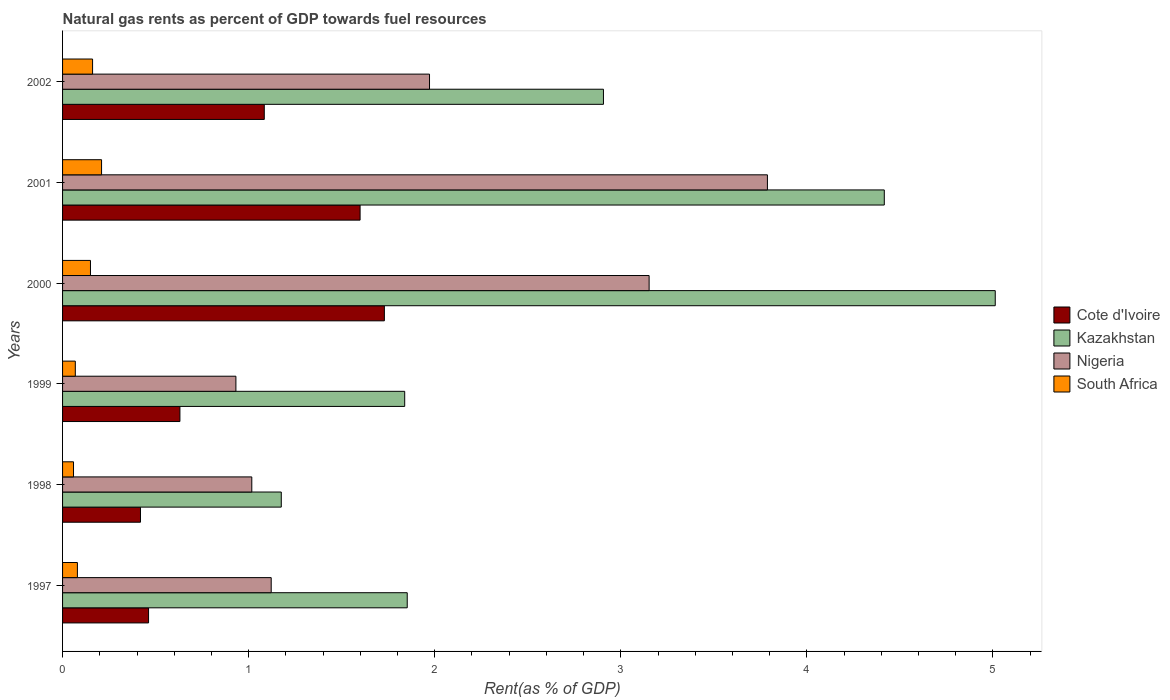Are the number of bars per tick equal to the number of legend labels?
Your answer should be very brief. Yes. Are the number of bars on each tick of the Y-axis equal?
Offer a terse response. Yes. How many bars are there on the 5th tick from the bottom?
Make the answer very short. 4. What is the label of the 1st group of bars from the top?
Offer a very short reply. 2002. In how many cases, is the number of bars for a given year not equal to the number of legend labels?
Make the answer very short. 0. What is the matural gas rent in Nigeria in 2000?
Make the answer very short. 3.15. Across all years, what is the maximum matural gas rent in Kazakhstan?
Ensure brevity in your answer.  5.01. Across all years, what is the minimum matural gas rent in Nigeria?
Offer a terse response. 0.93. What is the total matural gas rent in Nigeria in the graph?
Your answer should be compact. 11.98. What is the difference between the matural gas rent in Cote d'Ivoire in 1997 and that in 1998?
Offer a very short reply. 0.04. What is the difference between the matural gas rent in Nigeria in 1997 and the matural gas rent in South Africa in 2001?
Offer a terse response. 0.91. What is the average matural gas rent in Cote d'Ivoire per year?
Provide a short and direct response. 0.99. In the year 2000, what is the difference between the matural gas rent in South Africa and matural gas rent in Kazakhstan?
Offer a terse response. -4.86. In how many years, is the matural gas rent in Cote d'Ivoire greater than 4.8 %?
Your answer should be compact. 0. What is the ratio of the matural gas rent in Nigeria in 2001 to that in 2002?
Your answer should be very brief. 1.92. What is the difference between the highest and the second highest matural gas rent in South Africa?
Offer a terse response. 0.05. What is the difference between the highest and the lowest matural gas rent in Nigeria?
Keep it short and to the point. 2.86. In how many years, is the matural gas rent in Nigeria greater than the average matural gas rent in Nigeria taken over all years?
Keep it short and to the point. 2. What does the 4th bar from the top in 2002 represents?
Offer a terse response. Cote d'Ivoire. What does the 1st bar from the bottom in 2000 represents?
Offer a very short reply. Cote d'Ivoire. Is it the case that in every year, the sum of the matural gas rent in Kazakhstan and matural gas rent in Cote d'Ivoire is greater than the matural gas rent in South Africa?
Offer a very short reply. Yes. Does the graph contain grids?
Offer a very short reply. No. Where does the legend appear in the graph?
Provide a short and direct response. Center right. How are the legend labels stacked?
Ensure brevity in your answer.  Vertical. What is the title of the graph?
Provide a short and direct response. Natural gas rents as percent of GDP towards fuel resources. Does "Honduras" appear as one of the legend labels in the graph?
Provide a short and direct response. No. What is the label or title of the X-axis?
Provide a succinct answer. Rent(as % of GDP). What is the Rent(as % of GDP) in Cote d'Ivoire in 1997?
Keep it short and to the point. 0.46. What is the Rent(as % of GDP) of Kazakhstan in 1997?
Your answer should be compact. 1.85. What is the Rent(as % of GDP) of Nigeria in 1997?
Make the answer very short. 1.12. What is the Rent(as % of GDP) in South Africa in 1997?
Provide a short and direct response. 0.08. What is the Rent(as % of GDP) in Cote d'Ivoire in 1998?
Keep it short and to the point. 0.42. What is the Rent(as % of GDP) in Kazakhstan in 1998?
Your response must be concise. 1.18. What is the Rent(as % of GDP) of Nigeria in 1998?
Offer a very short reply. 1.02. What is the Rent(as % of GDP) of South Africa in 1998?
Provide a short and direct response. 0.06. What is the Rent(as % of GDP) in Cote d'Ivoire in 1999?
Provide a short and direct response. 0.63. What is the Rent(as % of GDP) of Kazakhstan in 1999?
Provide a succinct answer. 1.84. What is the Rent(as % of GDP) in Nigeria in 1999?
Your response must be concise. 0.93. What is the Rent(as % of GDP) of South Africa in 1999?
Offer a terse response. 0.07. What is the Rent(as % of GDP) of Cote d'Ivoire in 2000?
Provide a succinct answer. 1.73. What is the Rent(as % of GDP) in Kazakhstan in 2000?
Provide a succinct answer. 5.01. What is the Rent(as % of GDP) of Nigeria in 2000?
Offer a terse response. 3.15. What is the Rent(as % of GDP) of South Africa in 2000?
Ensure brevity in your answer.  0.15. What is the Rent(as % of GDP) in Cote d'Ivoire in 2001?
Provide a short and direct response. 1.6. What is the Rent(as % of GDP) of Kazakhstan in 2001?
Offer a terse response. 4.42. What is the Rent(as % of GDP) of Nigeria in 2001?
Your answer should be compact. 3.79. What is the Rent(as % of GDP) of South Africa in 2001?
Keep it short and to the point. 0.21. What is the Rent(as % of GDP) in Cote d'Ivoire in 2002?
Your answer should be compact. 1.08. What is the Rent(as % of GDP) of Kazakhstan in 2002?
Make the answer very short. 2.91. What is the Rent(as % of GDP) in Nigeria in 2002?
Provide a succinct answer. 1.97. What is the Rent(as % of GDP) of South Africa in 2002?
Offer a terse response. 0.16. Across all years, what is the maximum Rent(as % of GDP) in Cote d'Ivoire?
Your answer should be very brief. 1.73. Across all years, what is the maximum Rent(as % of GDP) of Kazakhstan?
Provide a succinct answer. 5.01. Across all years, what is the maximum Rent(as % of GDP) in Nigeria?
Keep it short and to the point. 3.79. Across all years, what is the maximum Rent(as % of GDP) in South Africa?
Keep it short and to the point. 0.21. Across all years, what is the minimum Rent(as % of GDP) of Cote d'Ivoire?
Provide a short and direct response. 0.42. Across all years, what is the minimum Rent(as % of GDP) in Kazakhstan?
Provide a short and direct response. 1.18. Across all years, what is the minimum Rent(as % of GDP) in Nigeria?
Keep it short and to the point. 0.93. Across all years, what is the minimum Rent(as % of GDP) of South Africa?
Your response must be concise. 0.06. What is the total Rent(as % of GDP) of Cote d'Ivoire in the graph?
Your response must be concise. 5.92. What is the total Rent(as % of GDP) in Kazakhstan in the graph?
Your response must be concise. 17.2. What is the total Rent(as % of GDP) in Nigeria in the graph?
Your response must be concise. 11.98. What is the total Rent(as % of GDP) of South Africa in the graph?
Provide a succinct answer. 0.73. What is the difference between the Rent(as % of GDP) of Cote d'Ivoire in 1997 and that in 1998?
Provide a succinct answer. 0.04. What is the difference between the Rent(as % of GDP) in Kazakhstan in 1997 and that in 1998?
Make the answer very short. 0.68. What is the difference between the Rent(as % of GDP) of Nigeria in 1997 and that in 1998?
Your answer should be very brief. 0.1. What is the difference between the Rent(as % of GDP) in South Africa in 1997 and that in 1998?
Give a very brief answer. 0.02. What is the difference between the Rent(as % of GDP) in Cote d'Ivoire in 1997 and that in 1999?
Give a very brief answer. -0.17. What is the difference between the Rent(as % of GDP) of Kazakhstan in 1997 and that in 1999?
Keep it short and to the point. 0.01. What is the difference between the Rent(as % of GDP) of Nigeria in 1997 and that in 1999?
Provide a succinct answer. 0.19. What is the difference between the Rent(as % of GDP) of South Africa in 1997 and that in 1999?
Give a very brief answer. 0.01. What is the difference between the Rent(as % of GDP) of Cote d'Ivoire in 1997 and that in 2000?
Your response must be concise. -1.27. What is the difference between the Rent(as % of GDP) in Kazakhstan in 1997 and that in 2000?
Offer a very short reply. -3.16. What is the difference between the Rent(as % of GDP) in Nigeria in 1997 and that in 2000?
Your answer should be compact. -2.03. What is the difference between the Rent(as % of GDP) of South Africa in 1997 and that in 2000?
Make the answer very short. -0.07. What is the difference between the Rent(as % of GDP) in Cote d'Ivoire in 1997 and that in 2001?
Offer a terse response. -1.14. What is the difference between the Rent(as % of GDP) in Kazakhstan in 1997 and that in 2001?
Your answer should be very brief. -2.56. What is the difference between the Rent(as % of GDP) of Nigeria in 1997 and that in 2001?
Make the answer very short. -2.67. What is the difference between the Rent(as % of GDP) of South Africa in 1997 and that in 2001?
Make the answer very short. -0.13. What is the difference between the Rent(as % of GDP) in Cote d'Ivoire in 1997 and that in 2002?
Make the answer very short. -0.62. What is the difference between the Rent(as % of GDP) of Kazakhstan in 1997 and that in 2002?
Make the answer very short. -1.05. What is the difference between the Rent(as % of GDP) of Nigeria in 1997 and that in 2002?
Your response must be concise. -0.85. What is the difference between the Rent(as % of GDP) in South Africa in 1997 and that in 2002?
Ensure brevity in your answer.  -0.08. What is the difference between the Rent(as % of GDP) of Cote d'Ivoire in 1998 and that in 1999?
Offer a terse response. -0.21. What is the difference between the Rent(as % of GDP) in Kazakhstan in 1998 and that in 1999?
Ensure brevity in your answer.  -0.66. What is the difference between the Rent(as % of GDP) in Nigeria in 1998 and that in 1999?
Offer a terse response. 0.09. What is the difference between the Rent(as % of GDP) in South Africa in 1998 and that in 1999?
Your response must be concise. -0.01. What is the difference between the Rent(as % of GDP) of Cote d'Ivoire in 1998 and that in 2000?
Your answer should be very brief. -1.31. What is the difference between the Rent(as % of GDP) of Kazakhstan in 1998 and that in 2000?
Give a very brief answer. -3.84. What is the difference between the Rent(as % of GDP) in Nigeria in 1998 and that in 2000?
Keep it short and to the point. -2.14. What is the difference between the Rent(as % of GDP) of South Africa in 1998 and that in 2000?
Provide a succinct answer. -0.09. What is the difference between the Rent(as % of GDP) of Cote d'Ivoire in 1998 and that in 2001?
Give a very brief answer. -1.18. What is the difference between the Rent(as % of GDP) of Kazakhstan in 1998 and that in 2001?
Ensure brevity in your answer.  -3.24. What is the difference between the Rent(as % of GDP) of Nigeria in 1998 and that in 2001?
Ensure brevity in your answer.  -2.77. What is the difference between the Rent(as % of GDP) in South Africa in 1998 and that in 2001?
Your answer should be very brief. -0.15. What is the difference between the Rent(as % of GDP) in Cote d'Ivoire in 1998 and that in 2002?
Your answer should be very brief. -0.67. What is the difference between the Rent(as % of GDP) in Kazakhstan in 1998 and that in 2002?
Give a very brief answer. -1.73. What is the difference between the Rent(as % of GDP) of Nigeria in 1998 and that in 2002?
Provide a short and direct response. -0.96. What is the difference between the Rent(as % of GDP) in South Africa in 1998 and that in 2002?
Offer a terse response. -0.1. What is the difference between the Rent(as % of GDP) of Cote d'Ivoire in 1999 and that in 2000?
Give a very brief answer. -1.1. What is the difference between the Rent(as % of GDP) in Kazakhstan in 1999 and that in 2000?
Your answer should be compact. -3.17. What is the difference between the Rent(as % of GDP) in Nigeria in 1999 and that in 2000?
Your answer should be very brief. -2.22. What is the difference between the Rent(as % of GDP) of South Africa in 1999 and that in 2000?
Offer a terse response. -0.08. What is the difference between the Rent(as % of GDP) of Cote d'Ivoire in 1999 and that in 2001?
Provide a short and direct response. -0.97. What is the difference between the Rent(as % of GDP) in Kazakhstan in 1999 and that in 2001?
Your response must be concise. -2.58. What is the difference between the Rent(as % of GDP) of Nigeria in 1999 and that in 2001?
Offer a terse response. -2.86. What is the difference between the Rent(as % of GDP) of South Africa in 1999 and that in 2001?
Your response must be concise. -0.14. What is the difference between the Rent(as % of GDP) of Cote d'Ivoire in 1999 and that in 2002?
Provide a succinct answer. -0.45. What is the difference between the Rent(as % of GDP) of Kazakhstan in 1999 and that in 2002?
Give a very brief answer. -1.07. What is the difference between the Rent(as % of GDP) of Nigeria in 1999 and that in 2002?
Ensure brevity in your answer.  -1.04. What is the difference between the Rent(as % of GDP) of South Africa in 1999 and that in 2002?
Ensure brevity in your answer.  -0.09. What is the difference between the Rent(as % of GDP) of Cote d'Ivoire in 2000 and that in 2001?
Your answer should be compact. 0.13. What is the difference between the Rent(as % of GDP) of Kazakhstan in 2000 and that in 2001?
Provide a succinct answer. 0.6. What is the difference between the Rent(as % of GDP) in Nigeria in 2000 and that in 2001?
Your answer should be compact. -0.64. What is the difference between the Rent(as % of GDP) in South Africa in 2000 and that in 2001?
Give a very brief answer. -0.06. What is the difference between the Rent(as % of GDP) in Cote d'Ivoire in 2000 and that in 2002?
Provide a succinct answer. 0.65. What is the difference between the Rent(as % of GDP) in Kazakhstan in 2000 and that in 2002?
Your response must be concise. 2.11. What is the difference between the Rent(as % of GDP) in Nigeria in 2000 and that in 2002?
Give a very brief answer. 1.18. What is the difference between the Rent(as % of GDP) of South Africa in 2000 and that in 2002?
Provide a succinct answer. -0.01. What is the difference between the Rent(as % of GDP) in Cote d'Ivoire in 2001 and that in 2002?
Your answer should be compact. 0.51. What is the difference between the Rent(as % of GDP) in Kazakhstan in 2001 and that in 2002?
Provide a succinct answer. 1.51. What is the difference between the Rent(as % of GDP) of Nigeria in 2001 and that in 2002?
Give a very brief answer. 1.82. What is the difference between the Rent(as % of GDP) in South Africa in 2001 and that in 2002?
Offer a terse response. 0.05. What is the difference between the Rent(as % of GDP) of Cote d'Ivoire in 1997 and the Rent(as % of GDP) of Kazakhstan in 1998?
Keep it short and to the point. -0.71. What is the difference between the Rent(as % of GDP) of Cote d'Ivoire in 1997 and the Rent(as % of GDP) of Nigeria in 1998?
Make the answer very short. -0.55. What is the difference between the Rent(as % of GDP) in Cote d'Ivoire in 1997 and the Rent(as % of GDP) in South Africa in 1998?
Provide a short and direct response. 0.4. What is the difference between the Rent(as % of GDP) in Kazakhstan in 1997 and the Rent(as % of GDP) in Nigeria in 1998?
Provide a short and direct response. 0.84. What is the difference between the Rent(as % of GDP) of Kazakhstan in 1997 and the Rent(as % of GDP) of South Africa in 1998?
Your answer should be very brief. 1.79. What is the difference between the Rent(as % of GDP) in Nigeria in 1997 and the Rent(as % of GDP) in South Africa in 1998?
Offer a terse response. 1.06. What is the difference between the Rent(as % of GDP) of Cote d'Ivoire in 1997 and the Rent(as % of GDP) of Kazakhstan in 1999?
Provide a short and direct response. -1.38. What is the difference between the Rent(as % of GDP) of Cote d'Ivoire in 1997 and the Rent(as % of GDP) of Nigeria in 1999?
Offer a very short reply. -0.47. What is the difference between the Rent(as % of GDP) in Cote d'Ivoire in 1997 and the Rent(as % of GDP) in South Africa in 1999?
Keep it short and to the point. 0.39. What is the difference between the Rent(as % of GDP) of Kazakhstan in 1997 and the Rent(as % of GDP) of Nigeria in 1999?
Provide a succinct answer. 0.92. What is the difference between the Rent(as % of GDP) of Kazakhstan in 1997 and the Rent(as % of GDP) of South Africa in 1999?
Provide a succinct answer. 1.78. What is the difference between the Rent(as % of GDP) of Nigeria in 1997 and the Rent(as % of GDP) of South Africa in 1999?
Offer a terse response. 1.05. What is the difference between the Rent(as % of GDP) of Cote d'Ivoire in 1997 and the Rent(as % of GDP) of Kazakhstan in 2000?
Keep it short and to the point. -4.55. What is the difference between the Rent(as % of GDP) of Cote d'Ivoire in 1997 and the Rent(as % of GDP) of Nigeria in 2000?
Your answer should be compact. -2.69. What is the difference between the Rent(as % of GDP) in Cote d'Ivoire in 1997 and the Rent(as % of GDP) in South Africa in 2000?
Give a very brief answer. 0.31. What is the difference between the Rent(as % of GDP) of Kazakhstan in 1997 and the Rent(as % of GDP) of Nigeria in 2000?
Make the answer very short. -1.3. What is the difference between the Rent(as % of GDP) of Kazakhstan in 1997 and the Rent(as % of GDP) of South Africa in 2000?
Your answer should be compact. 1.7. What is the difference between the Rent(as % of GDP) of Nigeria in 1997 and the Rent(as % of GDP) of South Africa in 2000?
Provide a short and direct response. 0.97. What is the difference between the Rent(as % of GDP) of Cote d'Ivoire in 1997 and the Rent(as % of GDP) of Kazakhstan in 2001?
Ensure brevity in your answer.  -3.95. What is the difference between the Rent(as % of GDP) of Cote d'Ivoire in 1997 and the Rent(as % of GDP) of Nigeria in 2001?
Keep it short and to the point. -3.33. What is the difference between the Rent(as % of GDP) in Cote d'Ivoire in 1997 and the Rent(as % of GDP) in South Africa in 2001?
Offer a terse response. 0.25. What is the difference between the Rent(as % of GDP) of Kazakhstan in 1997 and the Rent(as % of GDP) of Nigeria in 2001?
Your answer should be compact. -1.94. What is the difference between the Rent(as % of GDP) in Kazakhstan in 1997 and the Rent(as % of GDP) in South Africa in 2001?
Provide a succinct answer. 1.64. What is the difference between the Rent(as % of GDP) of Nigeria in 1997 and the Rent(as % of GDP) of South Africa in 2001?
Offer a very short reply. 0.91. What is the difference between the Rent(as % of GDP) in Cote d'Ivoire in 1997 and the Rent(as % of GDP) in Kazakhstan in 2002?
Provide a succinct answer. -2.44. What is the difference between the Rent(as % of GDP) in Cote d'Ivoire in 1997 and the Rent(as % of GDP) in Nigeria in 2002?
Offer a terse response. -1.51. What is the difference between the Rent(as % of GDP) in Cote d'Ivoire in 1997 and the Rent(as % of GDP) in South Africa in 2002?
Your answer should be compact. 0.3. What is the difference between the Rent(as % of GDP) in Kazakhstan in 1997 and the Rent(as % of GDP) in Nigeria in 2002?
Your response must be concise. -0.12. What is the difference between the Rent(as % of GDP) of Kazakhstan in 1997 and the Rent(as % of GDP) of South Africa in 2002?
Your answer should be compact. 1.69. What is the difference between the Rent(as % of GDP) in Cote d'Ivoire in 1998 and the Rent(as % of GDP) in Kazakhstan in 1999?
Your answer should be compact. -1.42. What is the difference between the Rent(as % of GDP) of Cote d'Ivoire in 1998 and the Rent(as % of GDP) of Nigeria in 1999?
Provide a short and direct response. -0.51. What is the difference between the Rent(as % of GDP) of Cote d'Ivoire in 1998 and the Rent(as % of GDP) of South Africa in 1999?
Your response must be concise. 0.35. What is the difference between the Rent(as % of GDP) in Kazakhstan in 1998 and the Rent(as % of GDP) in Nigeria in 1999?
Make the answer very short. 0.24. What is the difference between the Rent(as % of GDP) of Kazakhstan in 1998 and the Rent(as % of GDP) of South Africa in 1999?
Your response must be concise. 1.11. What is the difference between the Rent(as % of GDP) of Nigeria in 1998 and the Rent(as % of GDP) of South Africa in 1999?
Offer a terse response. 0.95. What is the difference between the Rent(as % of GDP) of Cote d'Ivoire in 1998 and the Rent(as % of GDP) of Kazakhstan in 2000?
Offer a very short reply. -4.59. What is the difference between the Rent(as % of GDP) of Cote d'Ivoire in 1998 and the Rent(as % of GDP) of Nigeria in 2000?
Your answer should be compact. -2.73. What is the difference between the Rent(as % of GDP) in Cote d'Ivoire in 1998 and the Rent(as % of GDP) in South Africa in 2000?
Your response must be concise. 0.27. What is the difference between the Rent(as % of GDP) of Kazakhstan in 1998 and the Rent(as % of GDP) of Nigeria in 2000?
Ensure brevity in your answer.  -1.98. What is the difference between the Rent(as % of GDP) in Kazakhstan in 1998 and the Rent(as % of GDP) in South Africa in 2000?
Give a very brief answer. 1.03. What is the difference between the Rent(as % of GDP) of Nigeria in 1998 and the Rent(as % of GDP) of South Africa in 2000?
Provide a short and direct response. 0.87. What is the difference between the Rent(as % of GDP) of Cote d'Ivoire in 1998 and the Rent(as % of GDP) of Kazakhstan in 2001?
Your response must be concise. -4. What is the difference between the Rent(as % of GDP) in Cote d'Ivoire in 1998 and the Rent(as % of GDP) in Nigeria in 2001?
Offer a very short reply. -3.37. What is the difference between the Rent(as % of GDP) of Cote d'Ivoire in 1998 and the Rent(as % of GDP) of South Africa in 2001?
Give a very brief answer. 0.21. What is the difference between the Rent(as % of GDP) of Kazakhstan in 1998 and the Rent(as % of GDP) of Nigeria in 2001?
Your answer should be very brief. -2.61. What is the difference between the Rent(as % of GDP) in Kazakhstan in 1998 and the Rent(as % of GDP) in South Africa in 2001?
Make the answer very short. 0.97. What is the difference between the Rent(as % of GDP) of Nigeria in 1998 and the Rent(as % of GDP) of South Africa in 2001?
Offer a very short reply. 0.81. What is the difference between the Rent(as % of GDP) in Cote d'Ivoire in 1998 and the Rent(as % of GDP) in Kazakhstan in 2002?
Your response must be concise. -2.49. What is the difference between the Rent(as % of GDP) in Cote d'Ivoire in 1998 and the Rent(as % of GDP) in Nigeria in 2002?
Offer a very short reply. -1.55. What is the difference between the Rent(as % of GDP) in Cote d'Ivoire in 1998 and the Rent(as % of GDP) in South Africa in 2002?
Give a very brief answer. 0.26. What is the difference between the Rent(as % of GDP) in Kazakhstan in 1998 and the Rent(as % of GDP) in Nigeria in 2002?
Make the answer very short. -0.8. What is the difference between the Rent(as % of GDP) of Kazakhstan in 1998 and the Rent(as % of GDP) of South Africa in 2002?
Keep it short and to the point. 1.01. What is the difference between the Rent(as % of GDP) of Nigeria in 1998 and the Rent(as % of GDP) of South Africa in 2002?
Keep it short and to the point. 0.86. What is the difference between the Rent(as % of GDP) of Cote d'Ivoire in 1999 and the Rent(as % of GDP) of Kazakhstan in 2000?
Give a very brief answer. -4.38. What is the difference between the Rent(as % of GDP) of Cote d'Ivoire in 1999 and the Rent(as % of GDP) of Nigeria in 2000?
Ensure brevity in your answer.  -2.52. What is the difference between the Rent(as % of GDP) in Cote d'Ivoire in 1999 and the Rent(as % of GDP) in South Africa in 2000?
Your answer should be compact. 0.48. What is the difference between the Rent(as % of GDP) in Kazakhstan in 1999 and the Rent(as % of GDP) in Nigeria in 2000?
Your answer should be very brief. -1.31. What is the difference between the Rent(as % of GDP) of Kazakhstan in 1999 and the Rent(as % of GDP) of South Africa in 2000?
Your answer should be very brief. 1.69. What is the difference between the Rent(as % of GDP) in Nigeria in 1999 and the Rent(as % of GDP) in South Africa in 2000?
Your response must be concise. 0.78. What is the difference between the Rent(as % of GDP) in Cote d'Ivoire in 1999 and the Rent(as % of GDP) in Kazakhstan in 2001?
Ensure brevity in your answer.  -3.79. What is the difference between the Rent(as % of GDP) of Cote d'Ivoire in 1999 and the Rent(as % of GDP) of Nigeria in 2001?
Your answer should be very brief. -3.16. What is the difference between the Rent(as % of GDP) in Cote d'Ivoire in 1999 and the Rent(as % of GDP) in South Africa in 2001?
Your response must be concise. 0.42. What is the difference between the Rent(as % of GDP) of Kazakhstan in 1999 and the Rent(as % of GDP) of Nigeria in 2001?
Offer a very short reply. -1.95. What is the difference between the Rent(as % of GDP) of Kazakhstan in 1999 and the Rent(as % of GDP) of South Africa in 2001?
Make the answer very short. 1.63. What is the difference between the Rent(as % of GDP) in Nigeria in 1999 and the Rent(as % of GDP) in South Africa in 2001?
Provide a short and direct response. 0.72. What is the difference between the Rent(as % of GDP) of Cote d'Ivoire in 1999 and the Rent(as % of GDP) of Kazakhstan in 2002?
Your answer should be compact. -2.28. What is the difference between the Rent(as % of GDP) in Cote d'Ivoire in 1999 and the Rent(as % of GDP) in Nigeria in 2002?
Give a very brief answer. -1.34. What is the difference between the Rent(as % of GDP) of Cote d'Ivoire in 1999 and the Rent(as % of GDP) of South Africa in 2002?
Your response must be concise. 0.47. What is the difference between the Rent(as % of GDP) of Kazakhstan in 1999 and the Rent(as % of GDP) of Nigeria in 2002?
Your response must be concise. -0.13. What is the difference between the Rent(as % of GDP) in Kazakhstan in 1999 and the Rent(as % of GDP) in South Africa in 2002?
Provide a succinct answer. 1.68. What is the difference between the Rent(as % of GDP) in Nigeria in 1999 and the Rent(as % of GDP) in South Africa in 2002?
Offer a terse response. 0.77. What is the difference between the Rent(as % of GDP) in Cote d'Ivoire in 2000 and the Rent(as % of GDP) in Kazakhstan in 2001?
Make the answer very short. -2.69. What is the difference between the Rent(as % of GDP) in Cote d'Ivoire in 2000 and the Rent(as % of GDP) in Nigeria in 2001?
Provide a succinct answer. -2.06. What is the difference between the Rent(as % of GDP) of Cote d'Ivoire in 2000 and the Rent(as % of GDP) of South Africa in 2001?
Ensure brevity in your answer.  1.52. What is the difference between the Rent(as % of GDP) in Kazakhstan in 2000 and the Rent(as % of GDP) in Nigeria in 2001?
Your answer should be compact. 1.22. What is the difference between the Rent(as % of GDP) of Kazakhstan in 2000 and the Rent(as % of GDP) of South Africa in 2001?
Provide a short and direct response. 4.8. What is the difference between the Rent(as % of GDP) of Nigeria in 2000 and the Rent(as % of GDP) of South Africa in 2001?
Offer a very short reply. 2.94. What is the difference between the Rent(as % of GDP) in Cote d'Ivoire in 2000 and the Rent(as % of GDP) in Kazakhstan in 2002?
Your answer should be compact. -1.18. What is the difference between the Rent(as % of GDP) in Cote d'Ivoire in 2000 and the Rent(as % of GDP) in Nigeria in 2002?
Your answer should be compact. -0.24. What is the difference between the Rent(as % of GDP) of Cote d'Ivoire in 2000 and the Rent(as % of GDP) of South Africa in 2002?
Provide a succinct answer. 1.57. What is the difference between the Rent(as % of GDP) of Kazakhstan in 2000 and the Rent(as % of GDP) of Nigeria in 2002?
Provide a short and direct response. 3.04. What is the difference between the Rent(as % of GDP) of Kazakhstan in 2000 and the Rent(as % of GDP) of South Africa in 2002?
Provide a succinct answer. 4.85. What is the difference between the Rent(as % of GDP) in Nigeria in 2000 and the Rent(as % of GDP) in South Africa in 2002?
Your answer should be compact. 2.99. What is the difference between the Rent(as % of GDP) in Cote d'Ivoire in 2001 and the Rent(as % of GDP) in Kazakhstan in 2002?
Ensure brevity in your answer.  -1.31. What is the difference between the Rent(as % of GDP) in Cote d'Ivoire in 2001 and the Rent(as % of GDP) in Nigeria in 2002?
Your answer should be compact. -0.37. What is the difference between the Rent(as % of GDP) of Cote d'Ivoire in 2001 and the Rent(as % of GDP) of South Africa in 2002?
Keep it short and to the point. 1.44. What is the difference between the Rent(as % of GDP) in Kazakhstan in 2001 and the Rent(as % of GDP) in Nigeria in 2002?
Your response must be concise. 2.44. What is the difference between the Rent(as % of GDP) in Kazakhstan in 2001 and the Rent(as % of GDP) in South Africa in 2002?
Make the answer very short. 4.25. What is the difference between the Rent(as % of GDP) in Nigeria in 2001 and the Rent(as % of GDP) in South Africa in 2002?
Offer a terse response. 3.63. What is the average Rent(as % of GDP) of Cote d'Ivoire per year?
Your answer should be very brief. 0.99. What is the average Rent(as % of GDP) in Kazakhstan per year?
Keep it short and to the point. 2.87. What is the average Rent(as % of GDP) of Nigeria per year?
Give a very brief answer. 2. What is the average Rent(as % of GDP) in South Africa per year?
Offer a terse response. 0.12. In the year 1997, what is the difference between the Rent(as % of GDP) in Cote d'Ivoire and Rent(as % of GDP) in Kazakhstan?
Offer a very short reply. -1.39. In the year 1997, what is the difference between the Rent(as % of GDP) in Cote d'Ivoire and Rent(as % of GDP) in Nigeria?
Ensure brevity in your answer.  -0.66. In the year 1997, what is the difference between the Rent(as % of GDP) in Cote d'Ivoire and Rent(as % of GDP) in South Africa?
Your response must be concise. 0.38. In the year 1997, what is the difference between the Rent(as % of GDP) of Kazakhstan and Rent(as % of GDP) of Nigeria?
Provide a short and direct response. 0.73. In the year 1997, what is the difference between the Rent(as % of GDP) of Kazakhstan and Rent(as % of GDP) of South Africa?
Your response must be concise. 1.77. In the year 1997, what is the difference between the Rent(as % of GDP) in Nigeria and Rent(as % of GDP) in South Africa?
Provide a short and direct response. 1.04. In the year 1998, what is the difference between the Rent(as % of GDP) in Cote d'Ivoire and Rent(as % of GDP) in Kazakhstan?
Offer a terse response. -0.76. In the year 1998, what is the difference between the Rent(as % of GDP) in Cote d'Ivoire and Rent(as % of GDP) in Nigeria?
Ensure brevity in your answer.  -0.6. In the year 1998, what is the difference between the Rent(as % of GDP) in Cote d'Ivoire and Rent(as % of GDP) in South Africa?
Your answer should be compact. 0.36. In the year 1998, what is the difference between the Rent(as % of GDP) of Kazakhstan and Rent(as % of GDP) of Nigeria?
Your response must be concise. 0.16. In the year 1998, what is the difference between the Rent(as % of GDP) of Kazakhstan and Rent(as % of GDP) of South Africa?
Give a very brief answer. 1.12. In the year 1998, what is the difference between the Rent(as % of GDP) of Nigeria and Rent(as % of GDP) of South Africa?
Provide a succinct answer. 0.96. In the year 1999, what is the difference between the Rent(as % of GDP) of Cote d'Ivoire and Rent(as % of GDP) of Kazakhstan?
Give a very brief answer. -1.21. In the year 1999, what is the difference between the Rent(as % of GDP) in Cote d'Ivoire and Rent(as % of GDP) in Nigeria?
Ensure brevity in your answer.  -0.3. In the year 1999, what is the difference between the Rent(as % of GDP) in Cote d'Ivoire and Rent(as % of GDP) in South Africa?
Ensure brevity in your answer.  0.56. In the year 1999, what is the difference between the Rent(as % of GDP) of Kazakhstan and Rent(as % of GDP) of Nigeria?
Your response must be concise. 0.91. In the year 1999, what is the difference between the Rent(as % of GDP) in Kazakhstan and Rent(as % of GDP) in South Africa?
Offer a terse response. 1.77. In the year 1999, what is the difference between the Rent(as % of GDP) in Nigeria and Rent(as % of GDP) in South Africa?
Provide a succinct answer. 0.86. In the year 2000, what is the difference between the Rent(as % of GDP) in Cote d'Ivoire and Rent(as % of GDP) in Kazakhstan?
Offer a very short reply. -3.28. In the year 2000, what is the difference between the Rent(as % of GDP) in Cote d'Ivoire and Rent(as % of GDP) in Nigeria?
Your answer should be compact. -1.42. In the year 2000, what is the difference between the Rent(as % of GDP) in Cote d'Ivoire and Rent(as % of GDP) in South Africa?
Offer a terse response. 1.58. In the year 2000, what is the difference between the Rent(as % of GDP) in Kazakhstan and Rent(as % of GDP) in Nigeria?
Your answer should be very brief. 1.86. In the year 2000, what is the difference between the Rent(as % of GDP) in Kazakhstan and Rent(as % of GDP) in South Africa?
Offer a terse response. 4.86. In the year 2000, what is the difference between the Rent(as % of GDP) in Nigeria and Rent(as % of GDP) in South Africa?
Your response must be concise. 3. In the year 2001, what is the difference between the Rent(as % of GDP) in Cote d'Ivoire and Rent(as % of GDP) in Kazakhstan?
Your response must be concise. -2.82. In the year 2001, what is the difference between the Rent(as % of GDP) in Cote d'Ivoire and Rent(as % of GDP) in Nigeria?
Your response must be concise. -2.19. In the year 2001, what is the difference between the Rent(as % of GDP) in Cote d'Ivoire and Rent(as % of GDP) in South Africa?
Offer a very short reply. 1.39. In the year 2001, what is the difference between the Rent(as % of GDP) in Kazakhstan and Rent(as % of GDP) in Nigeria?
Offer a very short reply. 0.63. In the year 2001, what is the difference between the Rent(as % of GDP) of Kazakhstan and Rent(as % of GDP) of South Africa?
Keep it short and to the point. 4.21. In the year 2001, what is the difference between the Rent(as % of GDP) in Nigeria and Rent(as % of GDP) in South Africa?
Your answer should be very brief. 3.58. In the year 2002, what is the difference between the Rent(as % of GDP) in Cote d'Ivoire and Rent(as % of GDP) in Kazakhstan?
Give a very brief answer. -1.82. In the year 2002, what is the difference between the Rent(as % of GDP) of Cote d'Ivoire and Rent(as % of GDP) of Nigeria?
Give a very brief answer. -0.89. In the year 2002, what is the difference between the Rent(as % of GDP) in Cote d'Ivoire and Rent(as % of GDP) in South Africa?
Ensure brevity in your answer.  0.92. In the year 2002, what is the difference between the Rent(as % of GDP) in Kazakhstan and Rent(as % of GDP) in Nigeria?
Keep it short and to the point. 0.93. In the year 2002, what is the difference between the Rent(as % of GDP) of Kazakhstan and Rent(as % of GDP) of South Africa?
Offer a terse response. 2.75. In the year 2002, what is the difference between the Rent(as % of GDP) in Nigeria and Rent(as % of GDP) in South Africa?
Offer a terse response. 1.81. What is the ratio of the Rent(as % of GDP) of Cote d'Ivoire in 1997 to that in 1998?
Offer a very short reply. 1.1. What is the ratio of the Rent(as % of GDP) in Kazakhstan in 1997 to that in 1998?
Your answer should be compact. 1.58. What is the ratio of the Rent(as % of GDP) in Nigeria in 1997 to that in 1998?
Your response must be concise. 1.1. What is the ratio of the Rent(as % of GDP) of South Africa in 1997 to that in 1998?
Make the answer very short. 1.36. What is the ratio of the Rent(as % of GDP) of Cote d'Ivoire in 1997 to that in 1999?
Your answer should be very brief. 0.73. What is the ratio of the Rent(as % of GDP) of Kazakhstan in 1997 to that in 1999?
Give a very brief answer. 1.01. What is the ratio of the Rent(as % of GDP) in Nigeria in 1997 to that in 1999?
Your response must be concise. 1.2. What is the ratio of the Rent(as % of GDP) of South Africa in 1997 to that in 1999?
Provide a succinct answer. 1.16. What is the ratio of the Rent(as % of GDP) in Cote d'Ivoire in 1997 to that in 2000?
Your response must be concise. 0.27. What is the ratio of the Rent(as % of GDP) of Kazakhstan in 1997 to that in 2000?
Ensure brevity in your answer.  0.37. What is the ratio of the Rent(as % of GDP) of Nigeria in 1997 to that in 2000?
Make the answer very short. 0.36. What is the ratio of the Rent(as % of GDP) of South Africa in 1997 to that in 2000?
Offer a very short reply. 0.53. What is the ratio of the Rent(as % of GDP) of Cote d'Ivoire in 1997 to that in 2001?
Give a very brief answer. 0.29. What is the ratio of the Rent(as % of GDP) of Kazakhstan in 1997 to that in 2001?
Keep it short and to the point. 0.42. What is the ratio of the Rent(as % of GDP) in Nigeria in 1997 to that in 2001?
Offer a terse response. 0.3. What is the ratio of the Rent(as % of GDP) of South Africa in 1997 to that in 2001?
Offer a very short reply. 0.38. What is the ratio of the Rent(as % of GDP) of Cote d'Ivoire in 1997 to that in 2002?
Your response must be concise. 0.43. What is the ratio of the Rent(as % of GDP) of Kazakhstan in 1997 to that in 2002?
Your answer should be compact. 0.64. What is the ratio of the Rent(as % of GDP) in Nigeria in 1997 to that in 2002?
Offer a very short reply. 0.57. What is the ratio of the Rent(as % of GDP) of South Africa in 1997 to that in 2002?
Give a very brief answer. 0.49. What is the ratio of the Rent(as % of GDP) of Cote d'Ivoire in 1998 to that in 1999?
Keep it short and to the point. 0.66. What is the ratio of the Rent(as % of GDP) in Kazakhstan in 1998 to that in 1999?
Offer a very short reply. 0.64. What is the ratio of the Rent(as % of GDP) of Nigeria in 1998 to that in 1999?
Provide a succinct answer. 1.09. What is the ratio of the Rent(as % of GDP) of South Africa in 1998 to that in 1999?
Provide a succinct answer. 0.86. What is the ratio of the Rent(as % of GDP) of Cote d'Ivoire in 1998 to that in 2000?
Your response must be concise. 0.24. What is the ratio of the Rent(as % of GDP) in Kazakhstan in 1998 to that in 2000?
Provide a short and direct response. 0.23. What is the ratio of the Rent(as % of GDP) in Nigeria in 1998 to that in 2000?
Provide a succinct answer. 0.32. What is the ratio of the Rent(as % of GDP) in South Africa in 1998 to that in 2000?
Ensure brevity in your answer.  0.39. What is the ratio of the Rent(as % of GDP) in Cote d'Ivoire in 1998 to that in 2001?
Your answer should be very brief. 0.26. What is the ratio of the Rent(as % of GDP) of Kazakhstan in 1998 to that in 2001?
Your response must be concise. 0.27. What is the ratio of the Rent(as % of GDP) of Nigeria in 1998 to that in 2001?
Your response must be concise. 0.27. What is the ratio of the Rent(as % of GDP) of South Africa in 1998 to that in 2001?
Your answer should be very brief. 0.28. What is the ratio of the Rent(as % of GDP) in Cote d'Ivoire in 1998 to that in 2002?
Ensure brevity in your answer.  0.39. What is the ratio of the Rent(as % of GDP) in Kazakhstan in 1998 to that in 2002?
Provide a short and direct response. 0.4. What is the ratio of the Rent(as % of GDP) in Nigeria in 1998 to that in 2002?
Your answer should be compact. 0.52. What is the ratio of the Rent(as % of GDP) of South Africa in 1998 to that in 2002?
Your answer should be very brief. 0.36. What is the ratio of the Rent(as % of GDP) of Cote d'Ivoire in 1999 to that in 2000?
Make the answer very short. 0.36. What is the ratio of the Rent(as % of GDP) in Kazakhstan in 1999 to that in 2000?
Give a very brief answer. 0.37. What is the ratio of the Rent(as % of GDP) in Nigeria in 1999 to that in 2000?
Provide a short and direct response. 0.3. What is the ratio of the Rent(as % of GDP) in South Africa in 1999 to that in 2000?
Provide a succinct answer. 0.46. What is the ratio of the Rent(as % of GDP) in Cote d'Ivoire in 1999 to that in 2001?
Make the answer very short. 0.39. What is the ratio of the Rent(as % of GDP) of Kazakhstan in 1999 to that in 2001?
Keep it short and to the point. 0.42. What is the ratio of the Rent(as % of GDP) of Nigeria in 1999 to that in 2001?
Provide a succinct answer. 0.25. What is the ratio of the Rent(as % of GDP) in South Africa in 1999 to that in 2001?
Offer a terse response. 0.33. What is the ratio of the Rent(as % of GDP) in Cote d'Ivoire in 1999 to that in 2002?
Ensure brevity in your answer.  0.58. What is the ratio of the Rent(as % of GDP) in Kazakhstan in 1999 to that in 2002?
Keep it short and to the point. 0.63. What is the ratio of the Rent(as % of GDP) of Nigeria in 1999 to that in 2002?
Provide a succinct answer. 0.47. What is the ratio of the Rent(as % of GDP) in South Africa in 1999 to that in 2002?
Give a very brief answer. 0.42. What is the ratio of the Rent(as % of GDP) of Cote d'Ivoire in 2000 to that in 2001?
Your response must be concise. 1.08. What is the ratio of the Rent(as % of GDP) of Kazakhstan in 2000 to that in 2001?
Your answer should be compact. 1.14. What is the ratio of the Rent(as % of GDP) of Nigeria in 2000 to that in 2001?
Offer a terse response. 0.83. What is the ratio of the Rent(as % of GDP) in South Africa in 2000 to that in 2001?
Your response must be concise. 0.72. What is the ratio of the Rent(as % of GDP) in Cote d'Ivoire in 2000 to that in 2002?
Give a very brief answer. 1.6. What is the ratio of the Rent(as % of GDP) in Kazakhstan in 2000 to that in 2002?
Provide a short and direct response. 1.72. What is the ratio of the Rent(as % of GDP) in Nigeria in 2000 to that in 2002?
Offer a terse response. 1.6. What is the ratio of the Rent(as % of GDP) in South Africa in 2000 to that in 2002?
Your answer should be very brief. 0.93. What is the ratio of the Rent(as % of GDP) in Cote d'Ivoire in 2001 to that in 2002?
Provide a succinct answer. 1.48. What is the ratio of the Rent(as % of GDP) in Kazakhstan in 2001 to that in 2002?
Keep it short and to the point. 1.52. What is the ratio of the Rent(as % of GDP) in Nigeria in 2001 to that in 2002?
Your answer should be very brief. 1.92. What is the ratio of the Rent(as % of GDP) in South Africa in 2001 to that in 2002?
Your response must be concise. 1.3. What is the difference between the highest and the second highest Rent(as % of GDP) of Cote d'Ivoire?
Offer a very short reply. 0.13. What is the difference between the highest and the second highest Rent(as % of GDP) of Kazakhstan?
Offer a very short reply. 0.6. What is the difference between the highest and the second highest Rent(as % of GDP) in Nigeria?
Ensure brevity in your answer.  0.64. What is the difference between the highest and the second highest Rent(as % of GDP) in South Africa?
Your answer should be compact. 0.05. What is the difference between the highest and the lowest Rent(as % of GDP) of Cote d'Ivoire?
Provide a short and direct response. 1.31. What is the difference between the highest and the lowest Rent(as % of GDP) in Kazakhstan?
Your response must be concise. 3.84. What is the difference between the highest and the lowest Rent(as % of GDP) in Nigeria?
Give a very brief answer. 2.86. What is the difference between the highest and the lowest Rent(as % of GDP) of South Africa?
Give a very brief answer. 0.15. 